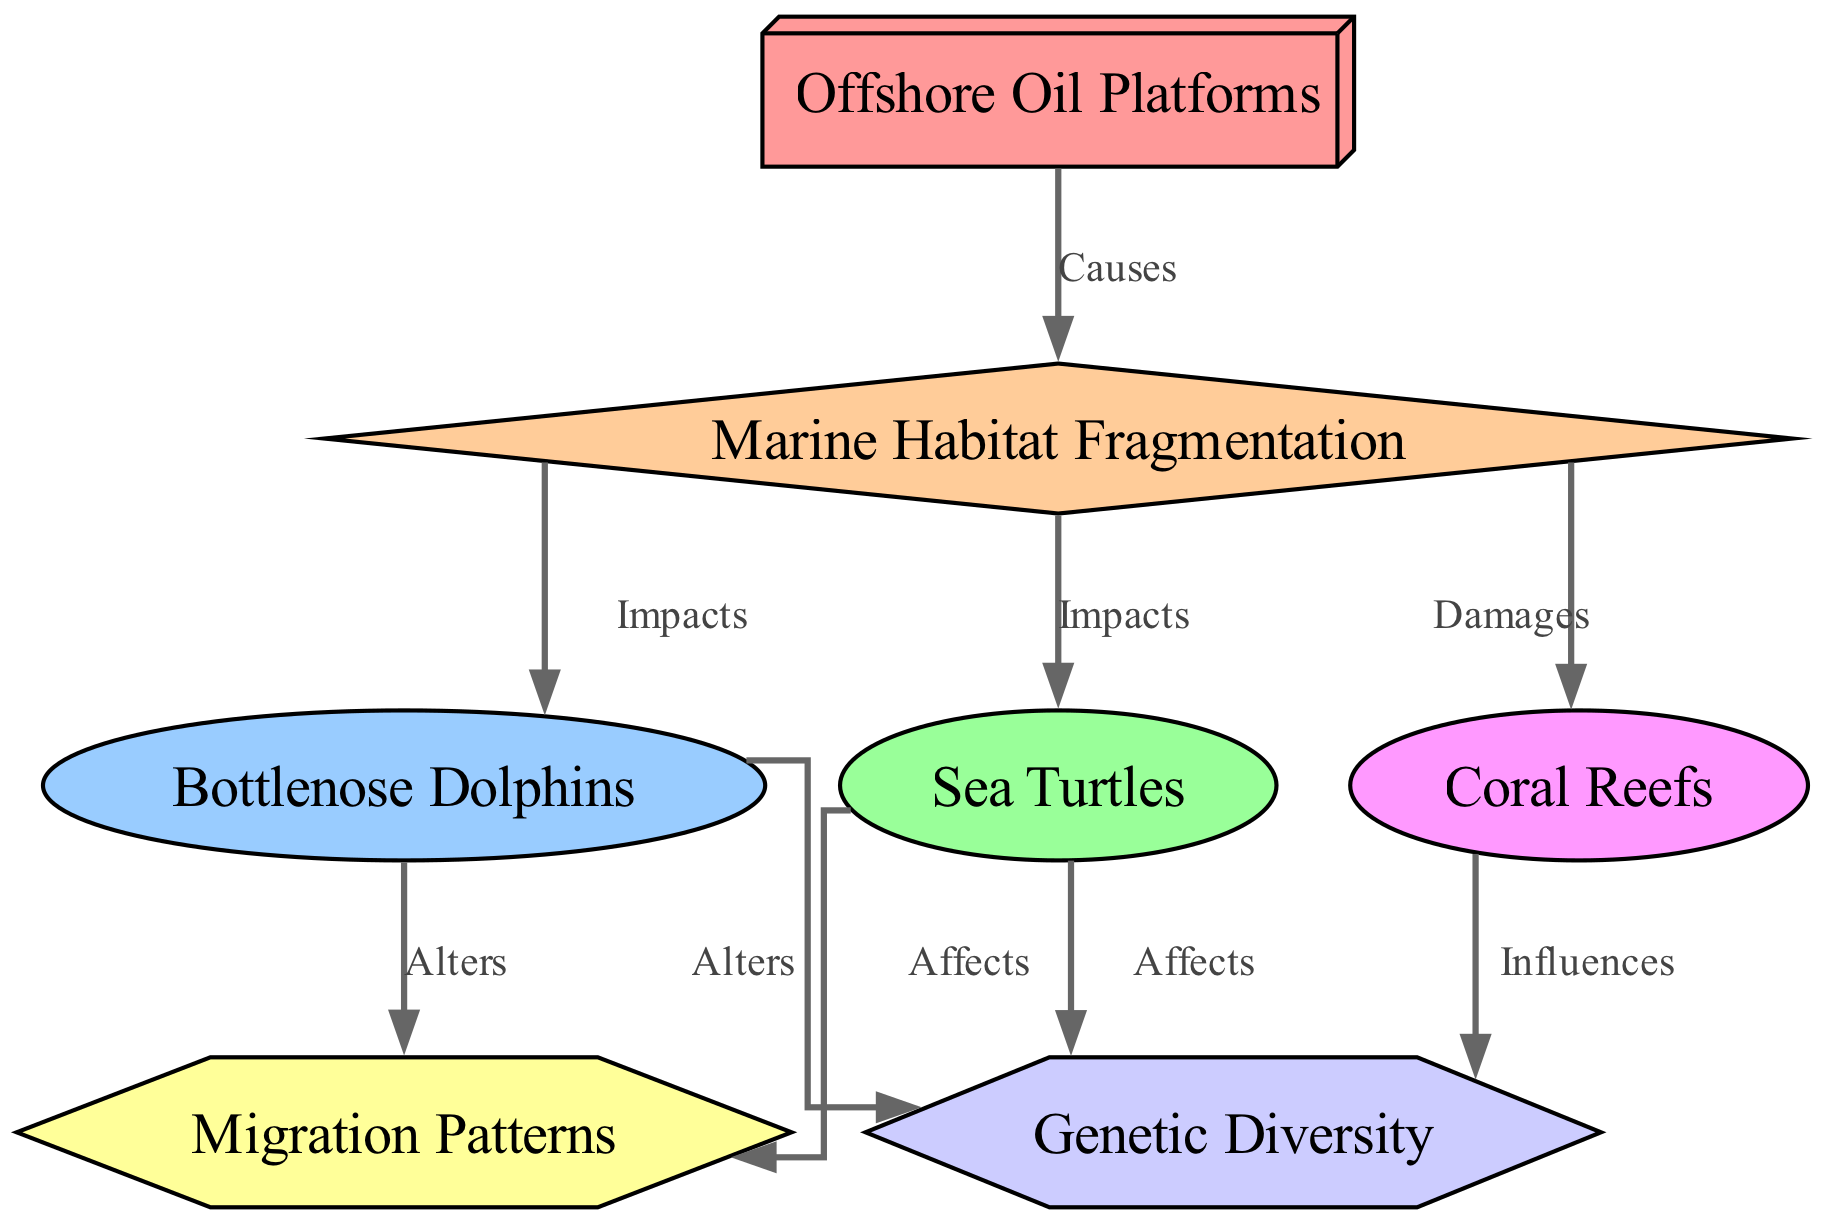What is the number of nodes in this directed graph? The graph consists of a total of 7 nodes, which include Offshore Oil Platforms, Marine Habitat Fragmentation, Bottlenose Dolphins, Sea Turtles, Coral Reefs, Genetic Diversity, and Migration Patterns.
Answer: 7 Which two nodes are directly impacted by Marine Habitat Fragmentation? Marine Habitat Fragmentation has directed edges toward Bottlenose Dolphins and Sea Turtles, indicating that both of these species are impacted directly by the fragmentation caused by offshore oil platforms.
Answer: Bottlenose Dolphins and Sea Turtles What type of relationship exists between Offshore Oil Platforms and Marine Habitat Fragmentation? The relationship is marked as "Causes," indicating that offshore oil platforms lead to marine habitat fragmentation. This direct cause-effect relationship is represented by an edge from Offshore Oil Platforms to Marine Habitat Fragmentation.
Answer: Causes How many edges are there in total within the graph? To find the number of edges, we can count each connection between nodes. There are a total of 8 edges in the graph that showcase the relationships among the different species and concepts.
Answer: 8 What effect do both Bottlenose Dolphins and Sea Turtles have on Genetic Diversity? Both species affect Genetic Diversity, as indicated by the directed edges from Bottlenose Dolphins and Sea Turtles to Genetic Diversity labeled as "Affects." This signifies a negative or transformative impact each species has on genetic diversity.
Answer: Affects What impact does Marine Habitat Fragmentation have on Coral Reefs? Marine Habitat Fragmentation has a damaging impact on Coral Reefs, as denoted by the directed edge labeled "Damages" leading from Marine Habitat Fragmentation to Coral Reefs.
Answer: Damages In what way does Migration Patterns relate to both Bottlenose Dolphins and Sea Turtles? Migration Patterns are altered by both Bottlenose Dolphins and Sea Turtles, which is evident from the directed edges leading from both species to Migration Patterns. This indicates that the dynamics of migration are influenced by both species.
Answer: Alters Which node influences Genetic Diversity through its effects on Coral Reefs? The Coral Reefs node influences Genetic Diversity, as indicated by the directed edge labeled "Influences" that leads from Coral Reefs to Genetic Diversity. This shows that coral reefs play a role in determining the genetic diversity of the ecosystem.
Answer: Influences 